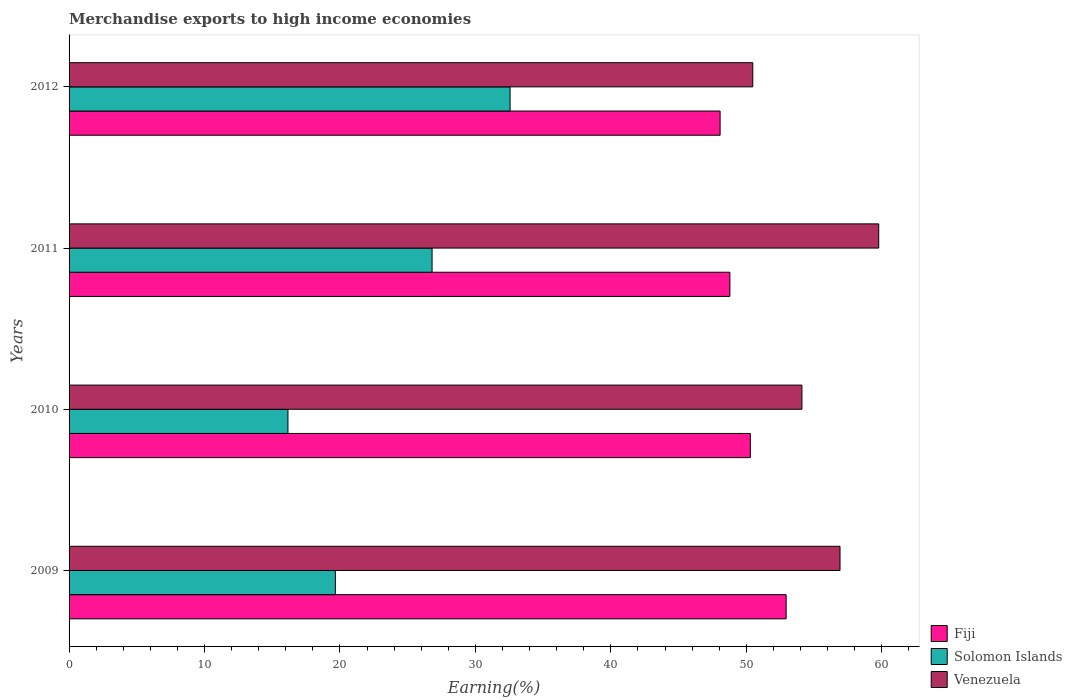How many different coloured bars are there?
Make the answer very short. 3. How many bars are there on the 1st tick from the bottom?
Make the answer very short. 3. In how many cases, is the number of bars for a given year not equal to the number of legend labels?
Give a very brief answer. 0. What is the percentage of amount earned from merchandise exports in Fiji in 2009?
Make the answer very short. 52.94. Across all years, what is the maximum percentage of amount earned from merchandise exports in Solomon Islands?
Make the answer very short. 32.56. Across all years, what is the minimum percentage of amount earned from merchandise exports in Fiji?
Your answer should be compact. 48.06. In which year was the percentage of amount earned from merchandise exports in Solomon Islands maximum?
Provide a short and direct response. 2012. In which year was the percentage of amount earned from merchandise exports in Venezuela minimum?
Provide a succinct answer. 2012. What is the total percentage of amount earned from merchandise exports in Venezuela in the graph?
Make the answer very short. 221.26. What is the difference between the percentage of amount earned from merchandise exports in Fiji in 2010 and that in 2012?
Ensure brevity in your answer.  2.23. What is the difference between the percentage of amount earned from merchandise exports in Solomon Islands in 2010 and the percentage of amount earned from merchandise exports in Venezuela in 2011?
Make the answer very short. -43.61. What is the average percentage of amount earned from merchandise exports in Fiji per year?
Provide a short and direct response. 50.02. In the year 2012, what is the difference between the percentage of amount earned from merchandise exports in Solomon Islands and percentage of amount earned from merchandise exports in Venezuela?
Your answer should be very brief. -17.92. In how many years, is the percentage of amount earned from merchandise exports in Fiji greater than 26 %?
Your answer should be very brief. 4. What is the ratio of the percentage of amount earned from merchandise exports in Solomon Islands in 2009 to that in 2010?
Keep it short and to the point. 1.22. What is the difference between the highest and the second highest percentage of amount earned from merchandise exports in Venezuela?
Keep it short and to the point. 2.86. What is the difference between the highest and the lowest percentage of amount earned from merchandise exports in Venezuela?
Your answer should be very brief. 9.3. Is the sum of the percentage of amount earned from merchandise exports in Venezuela in 2009 and 2012 greater than the maximum percentage of amount earned from merchandise exports in Fiji across all years?
Offer a terse response. Yes. What does the 2nd bar from the top in 2011 represents?
Your response must be concise. Solomon Islands. What does the 1st bar from the bottom in 2010 represents?
Offer a very short reply. Fiji. Is it the case that in every year, the sum of the percentage of amount earned from merchandise exports in Solomon Islands and percentage of amount earned from merchandise exports in Venezuela is greater than the percentage of amount earned from merchandise exports in Fiji?
Provide a succinct answer. Yes. How many bars are there?
Ensure brevity in your answer.  12. How many years are there in the graph?
Give a very brief answer. 4. Does the graph contain any zero values?
Offer a terse response. No. Where does the legend appear in the graph?
Your answer should be compact. Bottom right. How many legend labels are there?
Make the answer very short. 3. How are the legend labels stacked?
Make the answer very short. Vertical. What is the title of the graph?
Offer a terse response. Merchandise exports to high income economies. Does "Lithuania" appear as one of the legend labels in the graph?
Provide a short and direct response. No. What is the label or title of the X-axis?
Make the answer very short. Earning(%). What is the label or title of the Y-axis?
Your answer should be very brief. Years. What is the Earning(%) of Fiji in 2009?
Keep it short and to the point. 52.94. What is the Earning(%) of Solomon Islands in 2009?
Provide a short and direct response. 19.66. What is the Earning(%) in Venezuela in 2009?
Provide a succinct answer. 56.91. What is the Earning(%) in Fiji in 2010?
Your response must be concise. 50.29. What is the Earning(%) in Solomon Islands in 2010?
Offer a terse response. 16.16. What is the Earning(%) in Venezuela in 2010?
Keep it short and to the point. 54.1. What is the Earning(%) in Fiji in 2011?
Provide a short and direct response. 48.78. What is the Earning(%) in Solomon Islands in 2011?
Offer a terse response. 26.8. What is the Earning(%) of Venezuela in 2011?
Give a very brief answer. 59.77. What is the Earning(%) in Fiji in 2012?
Make the answer very short. 48.06. What is the Earning(%) of Solomon Islands in 2012?
Provide a short and direct response. 32.56. What is the Earning(%) of Venezuela in 2012?
Give a very brief answer. 50.47. Across all years, what is the maximum Earning(%) of Fiji?
Give a very brief answer. 52.94. Across all years, what is the maximum Earning(%) of Solomon Islands?
Your response must be concise. 32.56. Across all years, what is the maximum Earning(%) in Venezuela?
Make the answer very short. 59.77. Across all years, what is the minimum Earning(%) in Fiji?
Offer a terse response. 48.06. Across all years, what is the minimum Earning(%) of Solomon Islands?
Provide a short and direct response. 16.16. Across all years, what is the minimum Earning(%) in Venezuela?
Offer a terse response. 50.47. What is the total Earning(%) of Fiji in the graph?
Offer a very short reply. 200.08. What is the total Earning(%) of Solomon Islands in the graph?
Provide a succinct answer. 95.17. What is the total Earning(%) of Venezuela in the graph?
Offer a terse response. 221.26. What is the difference between the Earning(%) of Fiji in 2009 and that in 2010?
Ensure brevity in your answer.  2.64. What is the difference between the Earning(%) in Solomon Islands in 2009 and that in 2010?
Your answer should be very brief. 3.5. What is the difference between the Earning(%) of Venezuela in 2009 and that in 2010?
Ensure brevity in your answer.  2.81. What is the difference between the Earning(%) of Fiji in 2009 and that in 2011?
Provide a succinct answer. 4.15. What is the difference between the Earning(%) in Solomon Islands in 2009 and that in 2011?
Make the answer very short. -7.14. What is the difference between the Earning(%) in Venezuela in 2009 and that in 2011?
Give a very brief answer. -2.86. What is the difference between the Earning(%) of Fiji in 2009 and that in 2012?
Provide a succinct answer. 4.87. What is the difference between the Earning(%) of Solomon Islands in 2009 and that in 2012?
Ensure brevity in your answer.  -12.9. What is the difference between the Earning(%) in Venezuela in 2009 and that in 2012?
Offer a very short reply. 6.44. What is the difference between the Earning(%) of Fiji in 2010 and that in 2011?
Offer a terse response. 1.51. What is the difference between the Earning(%) of Solomon Islands in 2010 and that in 2011?
Make the answer very short. -10.64. What is the difference between the Earning(%) in Venezuela in 2010 and that in 2011?
Your answer should be compact. -5.67. What is the difference between the Earning(%) of Fiji in 2010 and that in 2012?
Make the answer very short. 2.23. What is the difference between the Earning(%) in Solomon Islands in 2010 and that in 2012?
Provide a short and direct response. -16.4. What is the difference between the Earning(%) of Venezuela in 2010 and that in 2012?
Your answer should be compact. 3.63. What is the difference between the Earning(%) in Fiji in 2011 and that in 2012?
Provide a succinct answer. 0.72. What is the difference between the Earning(%) of Solomon Islands in 2011 and that in 2012?
Your answer should be very brief. -5.76. What is the difference between the Earning(%) of Venezuela in 2011 and that in 2012?
Your response must be concise. 9.3. What is the difference between the Earning(%) in Fiji in 2009 and the Earning(%) in Solomon Islands in 2010?
Offer a very short reply. 36.78. What is the difference between the Earning(%) of Fiji in 2009 and the Earning(%) of Venezuela in 2010?
Make the answer very short. -1.17. What is the difference between the Earning(%) of Solomon Islands in 2009 and the Earning(%) of Venezuela in 2010?
Ensure brevity in your answer.  -34.45. What is the difference between the Earning(%) of Fiji in 2009 and the Earning(%) of Solomon Islands in 2011?
Your response must be concise. 26.14. What is the difference between the Earning(%) in Fiji in 2009 and the Earning(%) in Venezuela in 2011?
Make the answer very short. -6.83. What is the difference between the Earning(%) of Solomon Islands in 2009 and the Earning(%) of Venezuela in 2011?
Give a very brief answer. -40.11. What is the difference between the Earning(%) in Fiji in 2009 and the Earning(%) in Solomon Islands in 2012?
Give a very brief answer. 20.38. What is the difference between the Earning(%) of Fiji in 2009 and the Earning(%) of Venezuela in 2012?
Provide a succinct answer. 2.46. What is the difference between the Earning(%) in Solomon Islands in 2009 and the Earning(%) in Venezuela in 2012?
Offer a very short reply. -30.82. What is the difference between the Earning(%) of Fiji in 2010 and the Earning(%) of Solomon Islands in 2011?
Make the answer very short. 23.5. What is the difference between the Earning(%) of Fiji in 2010 and the Earning(%) of Venezuela in 2011?
Ensure brevity in your answer.  -9.48. What is the difference between the Earning(%) in Solomon Islands in 2010 and the Earning(%) in Venezuela in 2011?
Your answer should be compact. -43.61. What is the difference between the Earning(%) in Fiji in 2010 and the Earning(%) in Solomon Islands in 2012?
Provide a succinct answer. 17.74. What is the difference between the Earning(%) in Fiji in 2010 and the Earning(%) in Venezuela in 2012?
Keep it short and to the point. -0.18. What is the difference between the Earning(%) of Solomon Islands in 2010 and the Earning(%) of Venezuela in 2012?
Your answer should be very brief. -34.32. What is the difference between the Earning(%) of Fiji in 2011 and the Earning(%) of Solomon Islands in 2012?
Your response must be concise. 16.23. What is the difference between the Earning(%) in Fiji in 2011 and the Earning(%) in Venezuela in 2012?
Offer a terse response. -1.69. What is the difference between the Earning(%) in Solomon Islands in 2011 and the Earning(%) in Venezuela in 2012?
Give a very brief answer. -23.68. What is the average Earning(%) of Fiji per year?
Keep it short and to the point. 50.02. What is the average Earning(%) in Solomon Islands per year?
Provide a succinct answer. 23.79. What is the average Earning(%) of Venezuela per year?
Offer a very short reply. 55.32. In the year 2009, what is the difference between the Earning(%) of Fiji and Earning(%) of Solomon Islands?
Your answer should be compact. 33.28. In the year 2009, what is the difference between the Earning(%) in Fiji and Earning(%) in Venezuela?
Give a very brief answer. -3.98. In the year 2009, what is the difference between the Earning(%) of Solomon Islands and Earning(%) of Venezuela?
Your response must be concise. -37.26. In the year 2010, what is the difference between the Earning(%) of Fiji and Earning(%) of Solomon Islands?
Give a very brief answer. 34.14. In the year 2010, what is the difference between the Earning(%) of Fiji and Earning(%) of Venezuela?
Give a very brief answer. -3.81. In the year 2010, what is the difference between the Earning(%) in Solomon Islands and Earning(%) in Venezuela?
Offer a very short reply. -37.94. In the year 2011, what is the difference between the Earning(%) of Fiji and Earning(%) of Solomon Islands?
Provide a succinct answer. 21.98. In the year 2011, what is the difference between the Earning(%) of Fiji and Earning(%) of Venezuela?
Provide a succinct answer. -10.99. In the year 2011, what is the difference between the Earning(%) of Solomon Islands and Earning(%) of Venezuela?
Your response must be concise. -32.97. In the year 2012, what is the difference between the Earning(%) of Fiji and Earning(%) of Solomon Islands?
Provide a succinct answer. 15.5. In the year 2012, what is the difference between the Earning(%) of Fiji and Earning(%) of Venezuela?
Offer a very short reply. -2.41. In the year 2012, what is the difference between the Earning(%) of Solomon Islands and Earning(%) of Venezuela?
Your answer should be very brief. -17.92. What is the ratio of the Earning(%) of Fiji in 2009 to that in 2010?
Offer a very short reply. 1.05. What is the ratio of the Earning(%) of Solomon Islands in 2009 to that in 2010?
Keep it short and to the point. 1.22. What is the ratio of the Earning(%) in Venezuela in 2009 to that in 2010?
Make the answer very short. 1.05. What is the ratio of the Earning(%) in Fiji in 2009 to that in 2011?
Ensure brevity in your answer.  1.09. What is the ratio of the Earning(%) in Solomon Islands in 2009 to that in 2011?
Offer a terse response. 0.73. What is the ratio of the Earning(%) in Venezuela in 2009 to that in 2011?
Provide a succinct answer. 0.95. What is the ratio of the Earning(%) of Fiji in 2009 to that in 2012?
Your answer should be compact. 1.1. What is the ratio of the Earning(%) in Solomon Islands in 2009 to that in 2012?
Ensure brevity in your answer.  0.6. What is the ratio of the Earning(%) of Venezuela in 2009 to that in 2012?
Offer a terse response. 1.13. What is the ratio of the Earning(%) in Fiji in 2010 to that in 2011?
Keep it short and to the point. 1.03. What is the ratio of the Earning(%) of Solomon Islands in 2010 to that in 2011?
Offer a very short reply. 0.6. What is the ratio of the Earning(%) in Venezuela in 2010 to that in 2011?
Offer a terse response. 0.91. What is the ratio of the Earning(%) of Fiji in 2010 to that in 2012?
Offer a terse response. 1.05. What is the ratio of the Earning(%) of Solomon Islands in 2010 to that in 2012?
Your answer should be very brief. 0.5. What is the ratio of the Earning(%) of Venezuela in 2010 to that in 2012?
Your answer should be compact. 1.07. What is the ratio of the Earning(%) of Solomon Islands in 2011 to that in 2012?
Offer a very short reply. 0.82. What is the ratio of the Earning(%) in Venezuela in 2011 to that in 2012?
Ensure brevity in your answer.  1.18. What is the difference between the highest and the second highest Earning(%) in Fiji?
Offer a very short reply. 2.64. What is the difference between the highest and the second highest Earning(%) in Solomon Islands?
Keep it short and to the point. 5.76. What is the difference between the highest and the second highest Earning(%) in Venezuela?
Give a very brief answer. 2.86. What is the difference between the highest and the lowest Earning(%) of Fiji?
Offer a terse response. 4.87. What is the difference between the highest and the lowest Earning(%) in Solomon Islands?
Your answer should be compact. 16.4. What is the difference between the highest and the lowest Earning(%) of Venezuela?
Give a very brief answer. 9.3. 